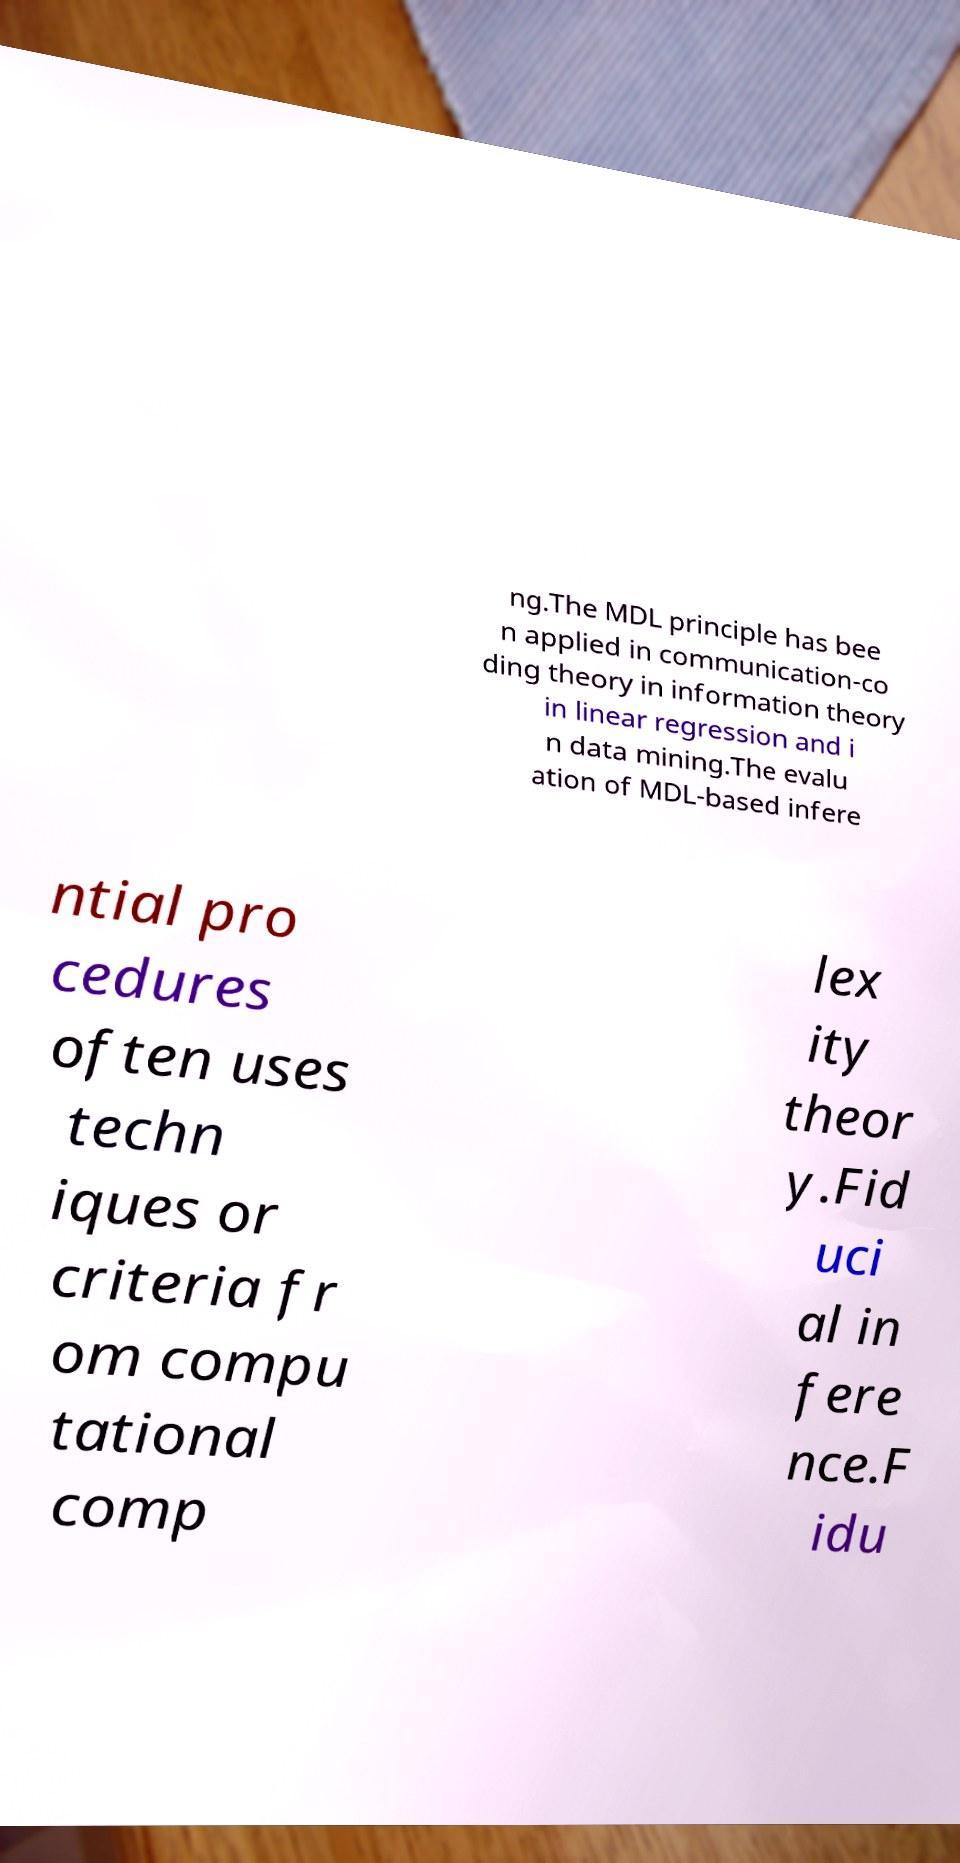For documentation purposes, I need the text within this image transcribed. Could you provide that? ng.The MDL principle has bee n applied in communication-co ding theory in information theory in linear regression and i n data mining.The evalu ation of MDL-based infere ntial pro cedures often uses techn iques or criteria fr om compu tational comp lex ity theor y.Fid uci al in fere nce.F idu 